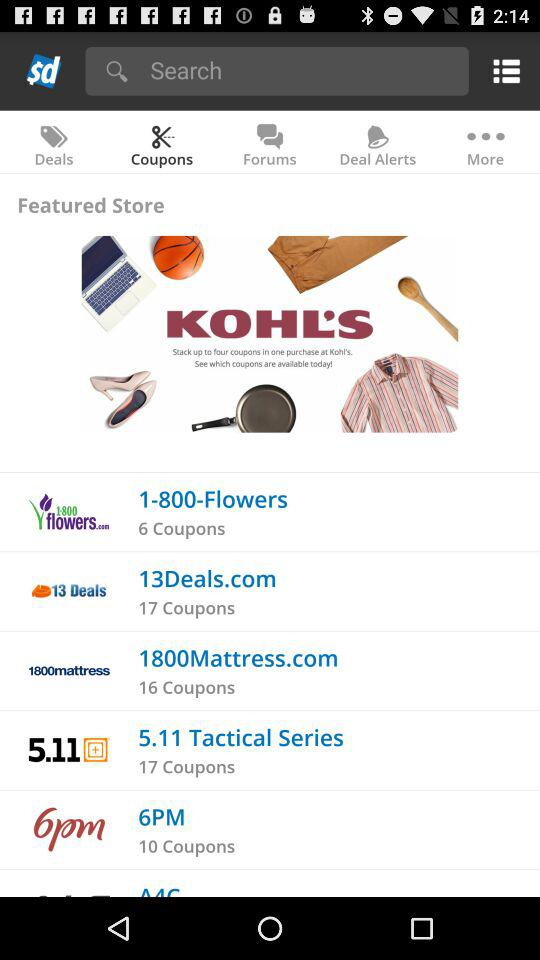Which tab is selected? The selected tab is "Coupons". 